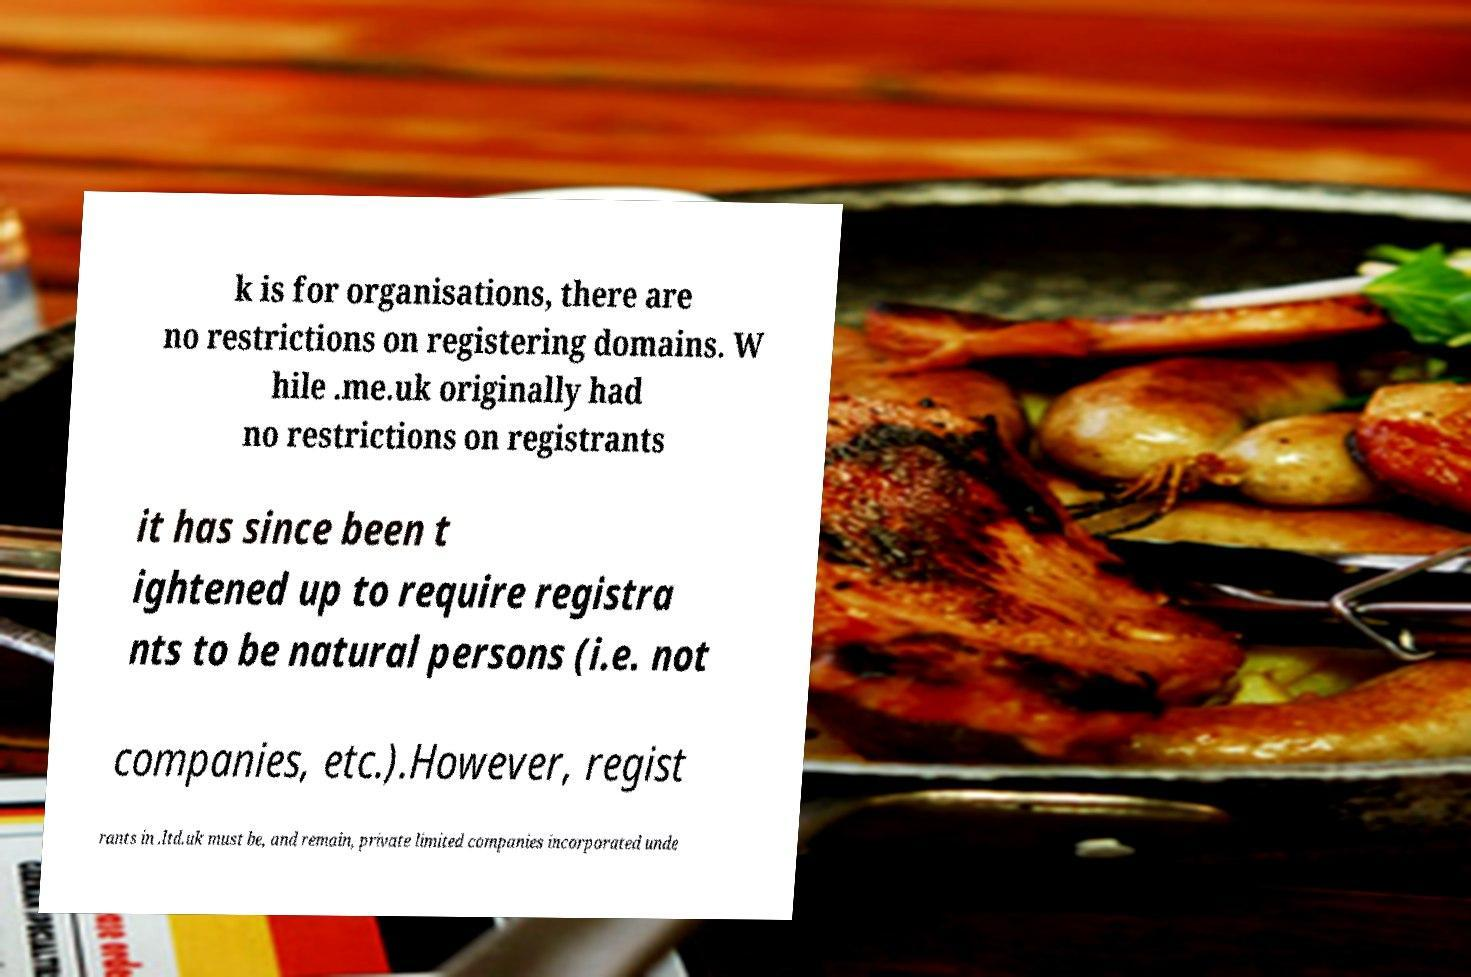Please read and relay the text visible in this image. What does it say? k is for organisations, there are no restrictions on registering domains. W hile .me.uk originally had no restrictions on registrants it has since been t ightened up to require registra nts to be natural persons (i.e. not companies, etc.).However, regist rants in .ltd.uk must be, and remain, private limited companies incorporated unde 